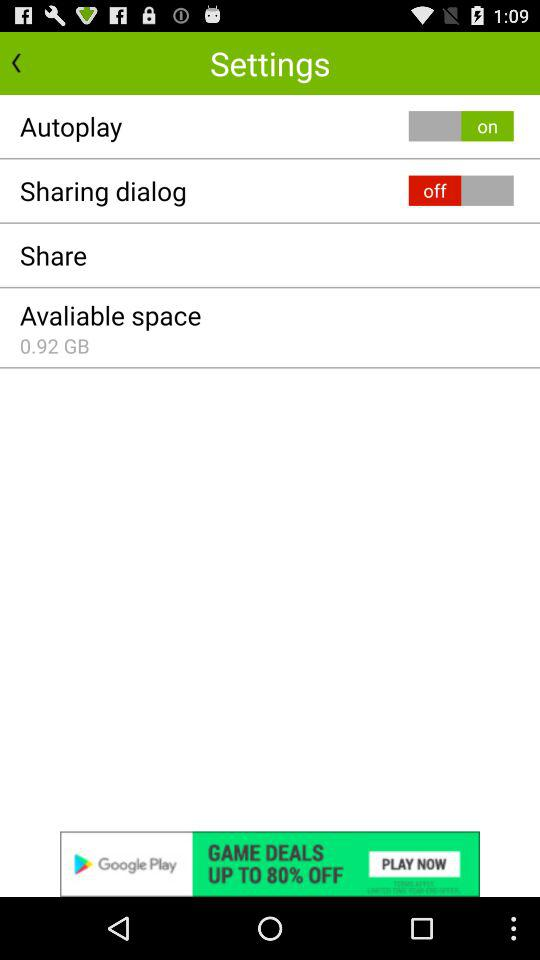What is the status of "Autoplay"? The status is "on". 